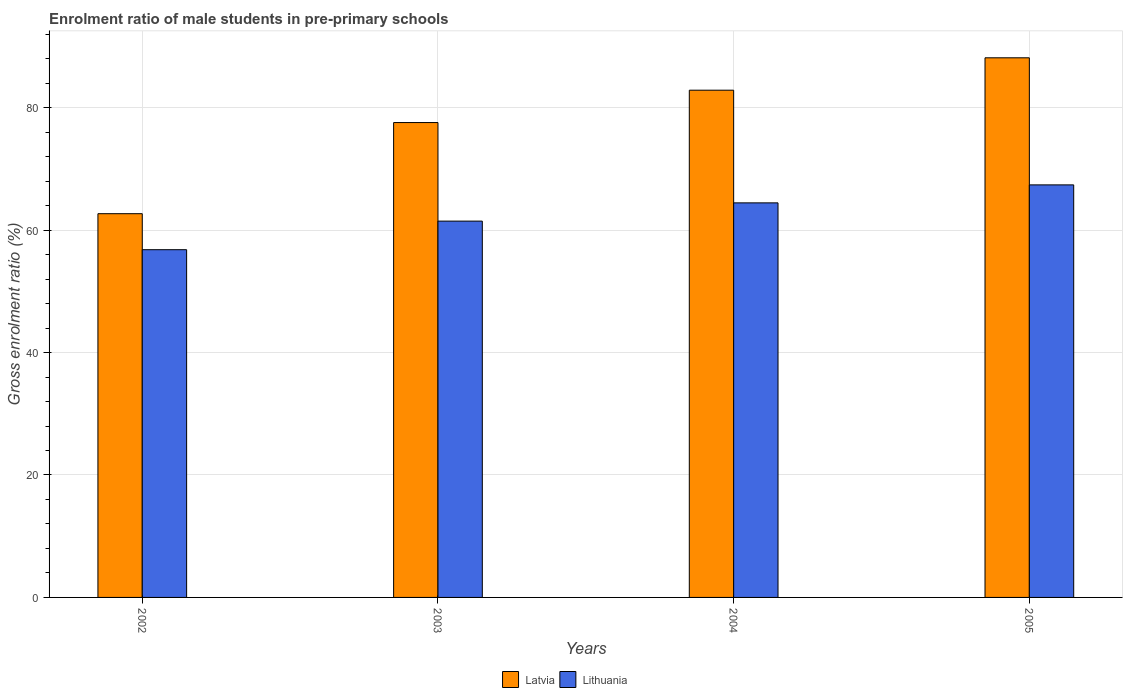How many different coloured bars are there?
Provide a succinct answer. 2. How many groups of bars are there?
Ensure brevity in your answer.  4. Are the number of bars per tick equal to the number of legend labels?
Provide a short and direct response. Yes. How many bars are there on the 1st tick from the left?
Make the answer very short. 2. In how many cases, is the number of bars for a given year not equal to the number of legend labels?
Make the answer very short. 0. What is the enrolment ratio of male students in pre-primary schools in Latvia in 2005?
Offer a terse response. 88.15. Across all years, what is the maximum enrolment ratio of male students in pre-primary schools in Lithuania?
Provide a short and direct response. 67.39. Across all years, what is the minimum enrolment ratio of male students in pre-primary schools in Latvia?
Offer a terse response. 62.69. In which year was the enrolment ratio of male students in pre-primary schools in Latvia maximum?
Offer a very short reply. 2005. In which year was the enrolment ratio of male students in pre-primary schools in Lithuania minimum?
Keep it short and to the point. 2002. What is the total enrolment ratio of male students in pre-primary schools in Lithuania in the graph?
Provide a succinct answer. 250.13. What is the difference between the enrolment ratio of male students in pre-primary schools in Lithuania in 2003 and that in 2005?
Ensure brevity in your answer.  -5.92. What is the difference between the enrolment ratio of male students in pre-primary schools in Latvia in 2005 and the enrolment ratio of male students in pre-primary schools in Lithuania in 2003?
Provide a short and direct response. 26.68. What is the average enrolment ratio of male students in pre-primary schools in Lithuania per year?
Provide a succinct answer. 62.53. In the year 2004, what is the difference between the enrolment ratio of male students in pre-primary schools in Latvia and enrolment ratio of male students in pre-primary schools in Lithuania?
Keep it short and to the point. 18.41. In how many years, is the enrolment ratio of male students in pre-primary schools in Lithuania greater than 68 %?
Provide a succinct answer. 0. What is the ratio of the enrolment ratio of male students in pre-primary schools in Lithuania in 2003 to that in 2004?
Provide a short and direct response. 0.95. Is the difference between the enrolment ratio of male students in pre-primary schools in Latvia in 2002 and 2005 greater than the difference between the enrolment ratio of male students in pre-primary schools in Lithuania in 2002 and 2005?
Make the answer very short. No. What is the difference between the highest and the second highest enrolment ratio of male students in pre-primary schools in Latvia?
Provide a short and direct response. 5.29. What is the difference between the highest and the lowest enrolment ratio of male students in pre-primary schools in Latvia?
Ensure brevity in your answer.  25.47. What does the 2nd bar from the left in 2005 represents?
Make the answer very short. Lithuania. What does the 1st bar from the right in 2003 represents?
Keep it short and to the point. Lithuania. How many bars are there?
Offer a terse response. 8. Are all the bars in the graph horizontal?
Ensure brevity in your answer.  No. How many years are there in the graph?
Offer a very short reply. 4. Are the values on the major ticks of Y-axis written in scientific E-notation?
Your response must be concise. No. Does the graph contain any zero values?
Your answer should be compact. No. Where does the legend appear in the graph?
Provide a short and direct response. Bottom center. How many legend labels are there?
Your response must be concise. 2. How are the legend labels stacked?
Keep it short and to the point. Horizontal. What is the title of the graph?
Your response must be concise. Enrolment ratio of male students in pre-primary schools. Does "St. Martin (French part)" appear as one of the legend labels in the graph?
Provide a succinct answer. No. What is the label or title of the X-axis?
Your response must be concise. Years. What is the label or title of the Y-axis?
Offer a terse response. Gross enrolment ratio (%). What is the Gross enrolment ratio (%) of Latvia in 2002?
Keep it short and to the point. 62.69. What is the Gross enrolment ratio (%) of Lithuania in 2002?
Offer a terse response. 56.81. What is the Gross enrolment ratio (%) of Latvia in 2003?
Your answer should be very brief. 77.58. What is the Gross enrolment ratio (%) in Lithuania in 2003?
Your answer should be very brief. 61.47. What is the Gross enrolment ratio (%) in Latvia in 2004?
Ensure brevity in your answer.  82.86. What is the Gross enrolment ratio (%) of Lithuania in 2004?
Your response must be concise. 64.45. What is the Gross enrolment ratio (%) in Latvia in 2005?
Ensure brevity in your answer.  88.15. What is the Gross enrolment ratio (%) of Lithuania in 2005?
Ensure brevity in your answer.  67.39. Across all years, what is the maximum Gross enrolment ratio (%) in Latvia?
Keep it short and to the point. 88.15. Across all years, what is the maximum Gross enrolment ratio (%) in Lithuania?
Your answer should be compact. 67.39. Across all years, what is the minimum Gross enrolment ratio (%) in Latvia?
Your answer should be very brief. 62.69. Across all years, what is the minimum Gross enrolment ratio (%) of Lithuania?
Provide a succinct answer. 56.81. What is the total Gross enrolment ratio (%) in Latvia in the graph?
Your answer should be very brief. 311.27. What is the total Gross enrolment ratio (%) of Lithuania in the graph?
Give a very brief answer. 250.13. What is the difference between the Gross enrolment ratio (%) in Latvia in 2002 and that in 2003?
Give a very brief answer. -14.89. What is the difference between the Gross enrolment ratio (%) of Lithuania in 2002 and that in 2003?
Keep it short and to the point. -4.67. What is the difference between the Gross enrolment ratio (%) in Latvia in 2002 and that in 2004?
Make the answer very short. -20.17. What is the difference between the Gross enrolment ratio (%) of Lithuania in 2002 and that in 2004?
Your answer should be very brief. -7.65. What is the difference between the Gross enrolment ratio (%) of Latvia in 2002 and that in 2005?
Make the answer very short. -25.47. What is the difference between the Gross enrolment ratio (%) of Lithuania in 2002 and that in 2005?
Your response must be concise. -10.59. What is the difference between the Gross enrolment ratio (%) of Latvia in 2003 and that in 2004?
Keep it short and to the point. -5.29. What is the difference between the Gross enrolment ratio (%) of Lithuania in 2003 and that in 2004?
Ensure brevity in your answer.  -2.98. What is the difference between the Gross enrolment ratio (%) in Latvia in 2003 and that in 2005?
Make the answer very short. -10.58. What is the difference between the Gross enrolment ratio (%) in Lithuania in 2003 and that in 2005?
Offer a very short reply. -5.92. What is the difference between the Gross enrolment ratio (%) in Latvia in 2004 and that in 2005?
Give a very brief answer. -5.29. What is the difference between the Gross enrolment ratio (%) of Lithuania in 2004 and that in 2005?
Offer a terse response. -2.94. What is the difference between the Gross enrolment ratio (%) of Latvia in 2002 and the Gross enrolment ratio (%) of Lithuania in 2003?
Offer a terse response. 1.21. What is the difference between the Gross enrolment ratio (%) of Latvia in 2002 and the Gross enrolment ratio (%) of Lithuania in 2004?
Offer a very short reply. -1.77. What is the difference between the Gross enrolment ratio (%) in Latvia in 2002 and the Gross enrolment ratio (%) in Lithuania in 2005?
Give a very brief answer. -4.71. What is the difference between the Gross enrolment ratio (%) in Latvia in 2003 and the Gross enrolment ratio (%) in Lithuania in 2004?
Make the answer very short. 13.12. What is the difference between the Gross enrolment ratio (%) in Latvia in 2003 and the Gross enrolment ratio (%) in Lithuania in 2005?
Keep it short and to the point. 10.18. What is the difference between the Gross enrolment ratio (%) in Latvia in 2004 and the Gross enrolment ratio (%) in Lithuania in 2005?
Offer a very short reply. 15.47. What is the average Gross enrolment ratio (%) of Latvia per year?
Make the answer very short. 77.82. What is the average Gross enrolment ratio (%) of Lithuania per year?
Provide a short and direct response. 62.53. In the year 2002, what is the difference between the Gross enrolment ratio (%) in Latvia and Gross enrolment ratio (%) in Lithuania?
Your answer should be very brief. 5.88. In the year 2003, what is the difference between the Gross enrolment ratio (%) of Latvia and Gross enrolment ratio (%) of Lithuania?
Provide a short and direct response. 16.1. In the year 2004, what is the difference between the Gross enrolment ratio (%) of Latvia and Gross enrolment ratio (%) of Lithuania?
Keep it short and to the point. 18.41. In the year 2005, what is the difference between the Gross enrolment ratio (%) of Latvia and Gross enrolment ratio (%) of Lithuania?
Keep it short and to the point. 20.76. What is the ratio of the Gross enrolment ratio (%) in Latvia in 2002 to that in 2003?
Offer a very short reply. 0.81. What is the ratio of the Gross enrolment ratio (%) of Lithuania in 2002 to that in 2003?
Your response must be concise. 0.92. What is the ratio of the Gross enrolment ratio (%) in Latvia in 2002 to that in 2004?
Make the answer very short. 0.76. What is the ratio of the Gross enrolment ratio (%) of Lithuania in 2002 to that in 2004?
Offer a very short reply. 0.88. What is the ratio of the Gross enrolment ratio (%) in Latvia in 2002 to that in 2005?
Make the answer very short. 0.71. What is the ratio of the Gross enrolment ratio (%) of Lithuania in 2002 to that in 2005?
Offer a terse response. 0.84. What is the ratio of the Gross enrolment ratio (%) of Latvia in 2003 to that in 2004?
Your answer should be very brief. 0.94. What is the ratio of the Gross enrolment ratio (%) in Lithuania in 2003 to that in 2004?
Make the answer very short. 0.95. What is the ratio of the Gross enrolment ratio (%) of Lithuania in 2003 to that in 2005?
Make the answer very short. 0.91. What is the ratio of the Gross enrolment ratio (%) in Lithuania in 2004 to that in 2005?
Offer a very short reply. 0.96. What is the difference between the highest and the second highest Gross enrolment ratio (%) of Latvia?
Offer a very short reply. 5.29. What is the difference between the highest and the second highest Gross enrolment ratio (%) in Lithuania?
Give a very brief answer. 2.94. What is the difference between the highest and the lowest Gross enrolment ratio (%) of Latvia?
Your answer should be very brief. 25.47. What is the difference between the highest and the lowest Gross enrolment ratio (%) in Lithuania?
Offer a very short reply. 10.59. 